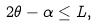Convert formula to latex. <formula><loc_0><loc_0><loc_500><loc_500>2 \theta - \alpha \leq L ,</formula> 